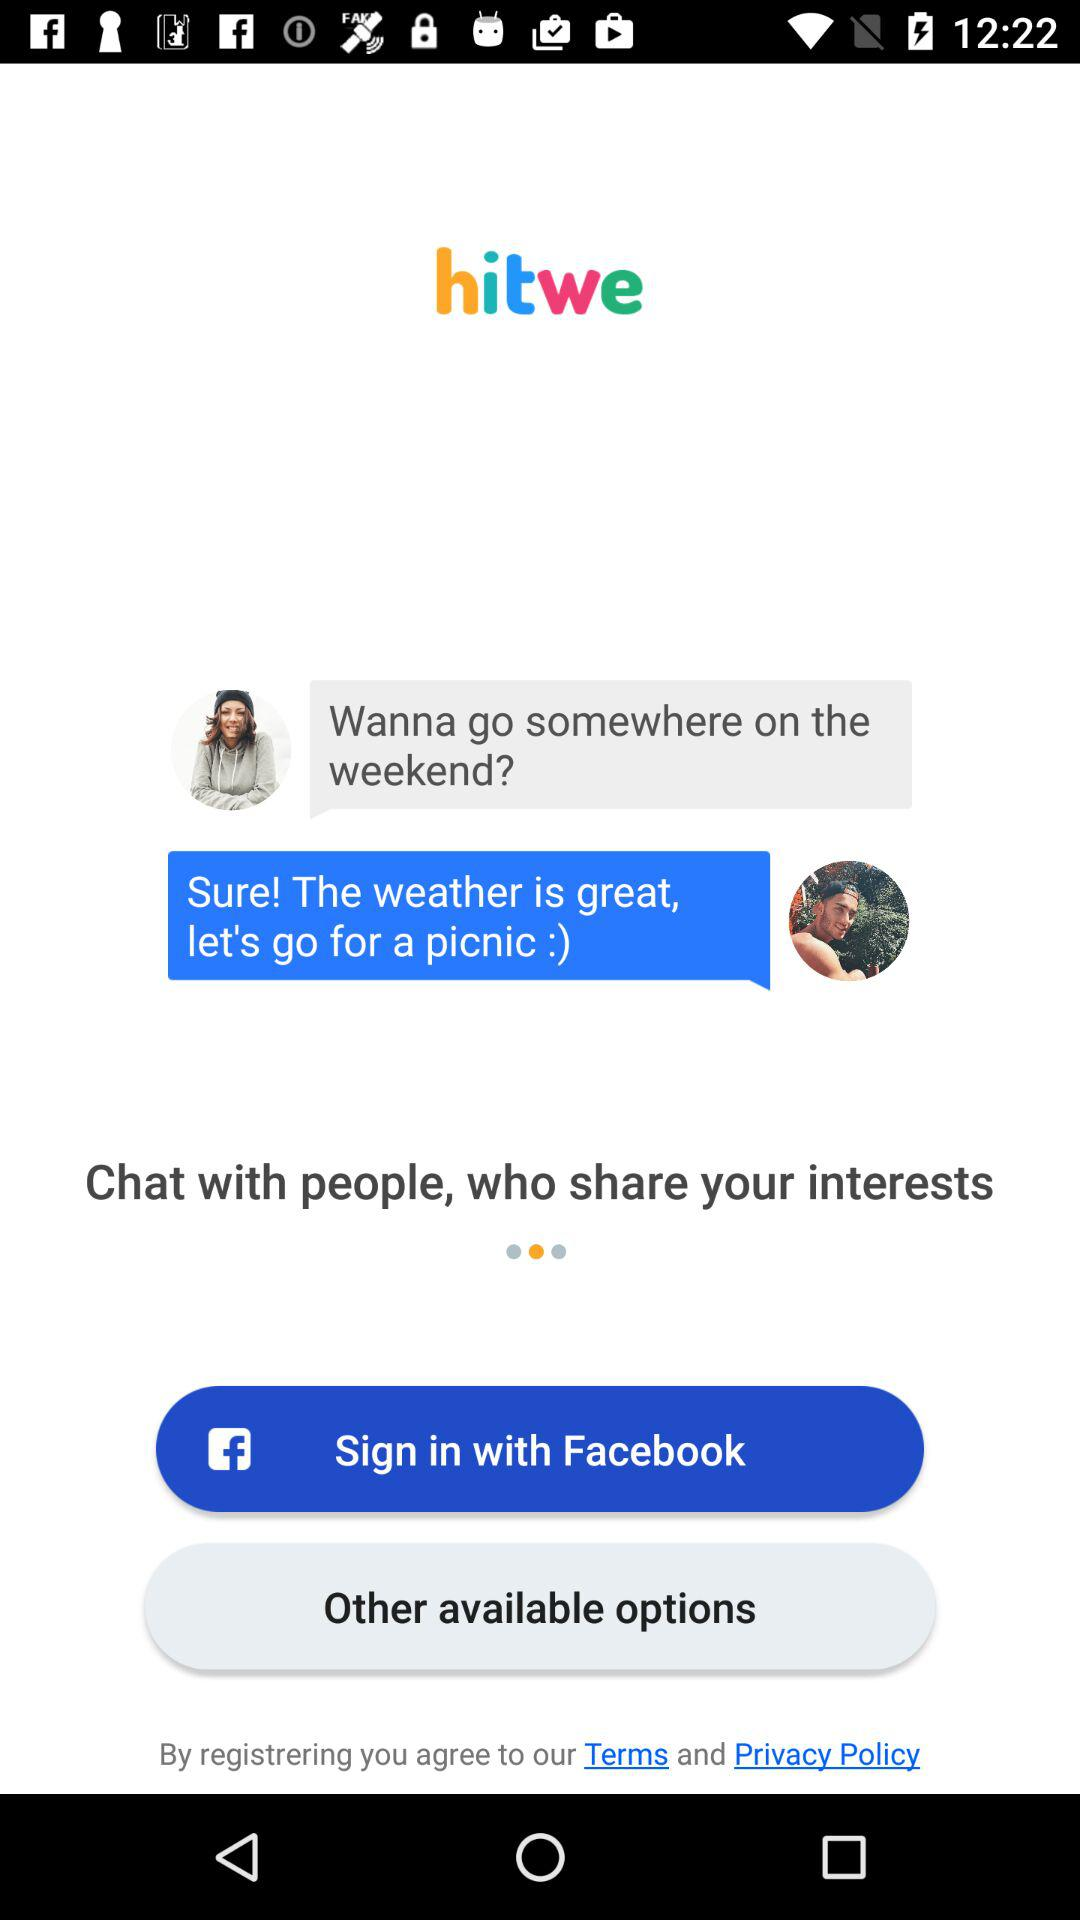What is the application name? The application name is "hitwe". 